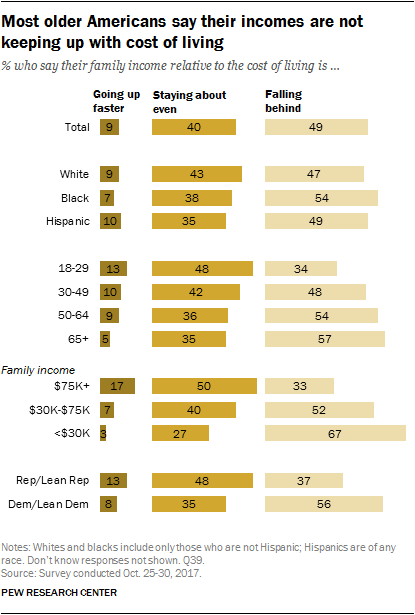Specify some key components in this picture. I have identified three values: 10, 35, and 49, and I have categorized them as Hispanic. The ratio between the three options in the total is approximately 0.403344907... 